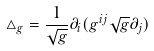Convert formula to latex. <formula><loc_0><loc_0><loc_500><loc_500>\triangle _ { g } = \frac { 1 } { \sqrt { g } } \partial _ { i } ( g ^ { i j } \sqrt { g } \partial _ { j } )</formula> 